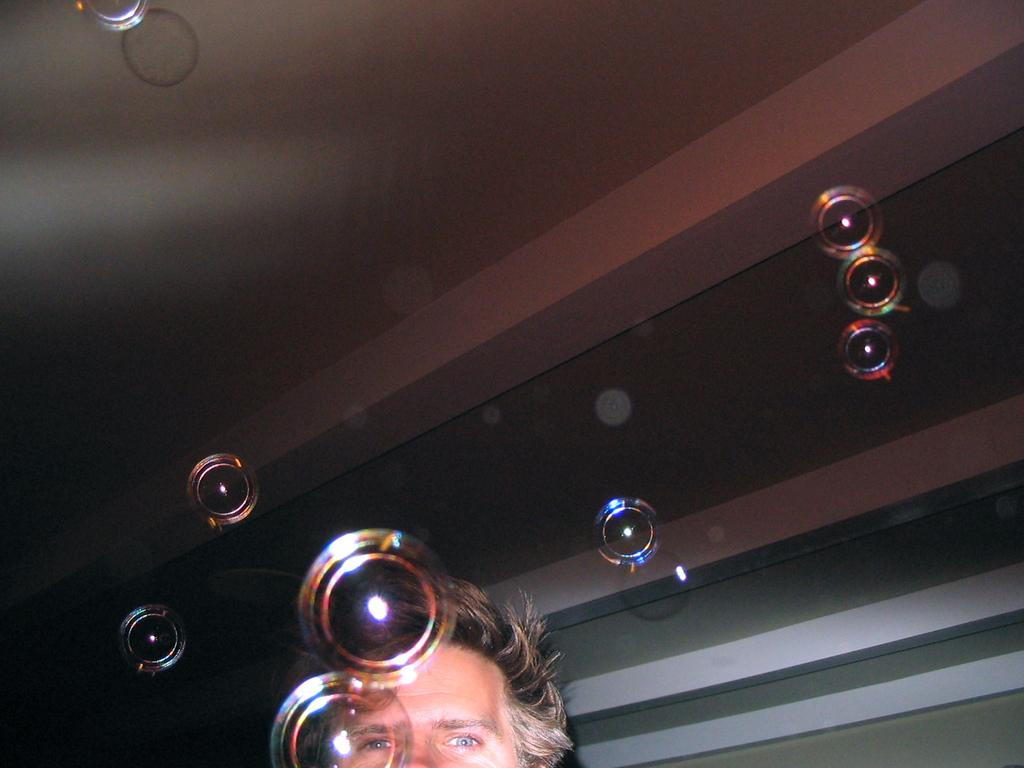Who or what is at the bottom of the image? There is a person at the bottom of the image. What can be seen in the background of the image? There are lights arranged in the background, along with a roof and a wall. What type of salt is being used to season the person's mouth in the image? There is no salt or mention of a mouth in the image; it only features a person and background elements. 